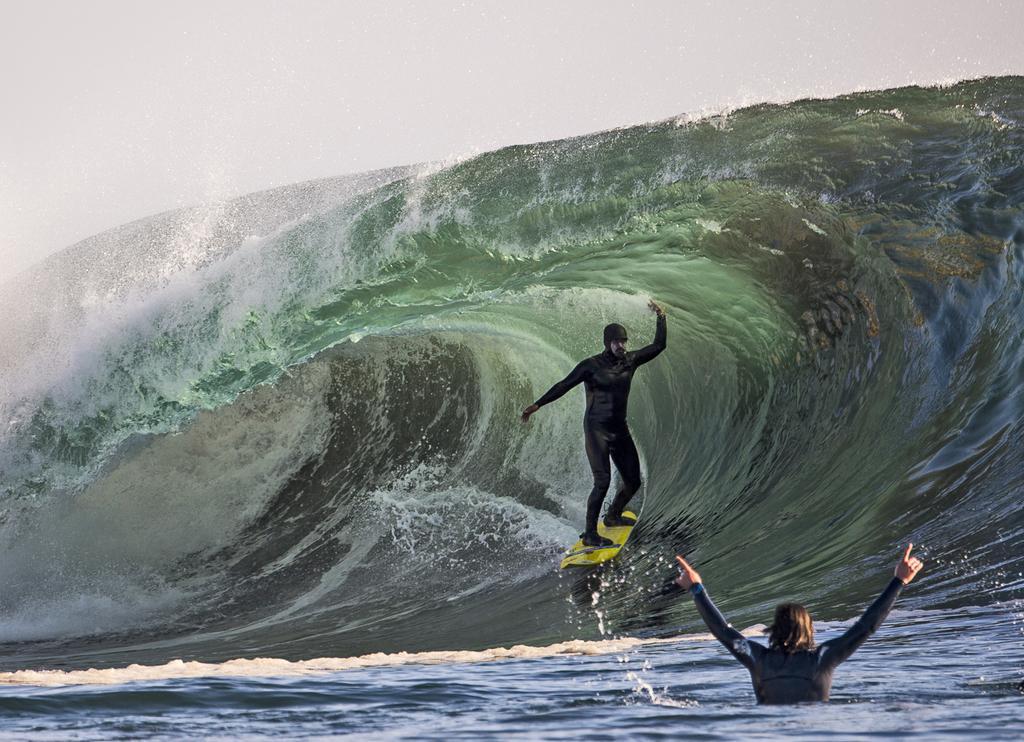Could you give a brief overview of what you see in this image? In the middle of this image, there is a person in black color dress, riding a surfboard on a tide of the ocean. Beside this time, there is another person in black color dress partially in the water of the ocean. 